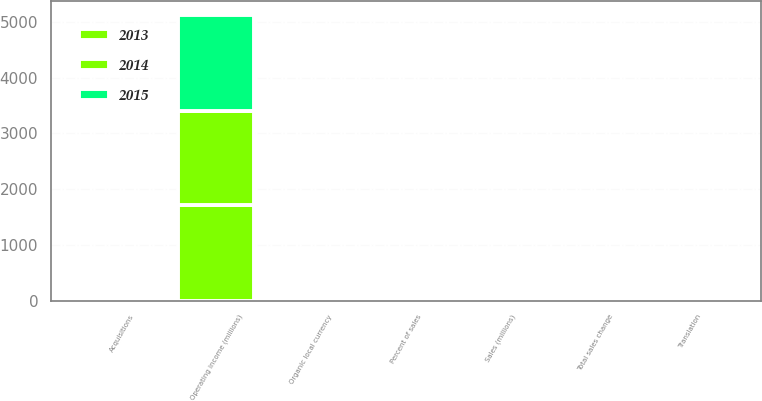Convert chart to OTSL. <chart><loc_0><loc_0><loc_500><loc_500><stacked_bar_chart><ecel><fcel>Sales (millions)<fcel>Organic local currency<fcel>Acquisitions<fcel>Translation<fcel>Total sales change<fcel>Operating income (millions)<fcel>Percent of sales<nl><fcel>2013<fcel>4.75<fcel>3.7<fcel>0.8<fcel>7.2<fcel>2.7<fcel>1724<fcel>31.8<nl><fcel>2015<fcel>4.75<fcel>5.8<fcel>0.4<fcel>1.7<fcel>4.5<fcel>1724<fcel>30.9<nl><fcel>2014<fcel>4.75<fcel>5<fcel>0.1<fcel>1.3<fcel>3.8<fcel>1672<fcel>31.3<nl></chart> 